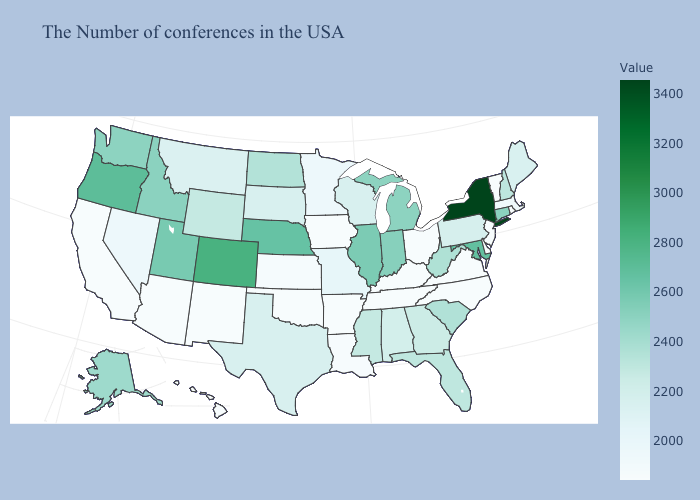Which states have the lowest value in the USA?
Give a very brief answer. Rhode Island, Vermont, New Jersey, Delaware, Virginia, North Carolina, Ohio, Kentucky, Tennessee, Arkansas, Iowa, Oklahoma, New Mexico, Arizona, California, Hawaii. Does the map have missing data?
Concise answer only. No. Does New Hampshire have the highest value in the Northeast?
Write a very short answer. No. Which states have the lowest value in the USA?
Give a very brief answer. Rhode Island, Vermont, New Jersey, Delaware, Virginia, North Carolina, Ohio, Kentucky, Tennessee, Arkansas, Iowa, Oklahoma, New Mexico, Arizona, California, Hawaii. Does the map have missing data?
Write a very short answer. No. Does Texas have the lowest value in the USA?
Quick response, please. No. 